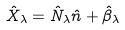<formula> <loc_0><loc_0><loc_500><loc_500>\hat { X } _ { \lambda } = \hat { N } _ { \lambda } \hat { n } + \hat { \beta } _ { \lambda }</formula> 